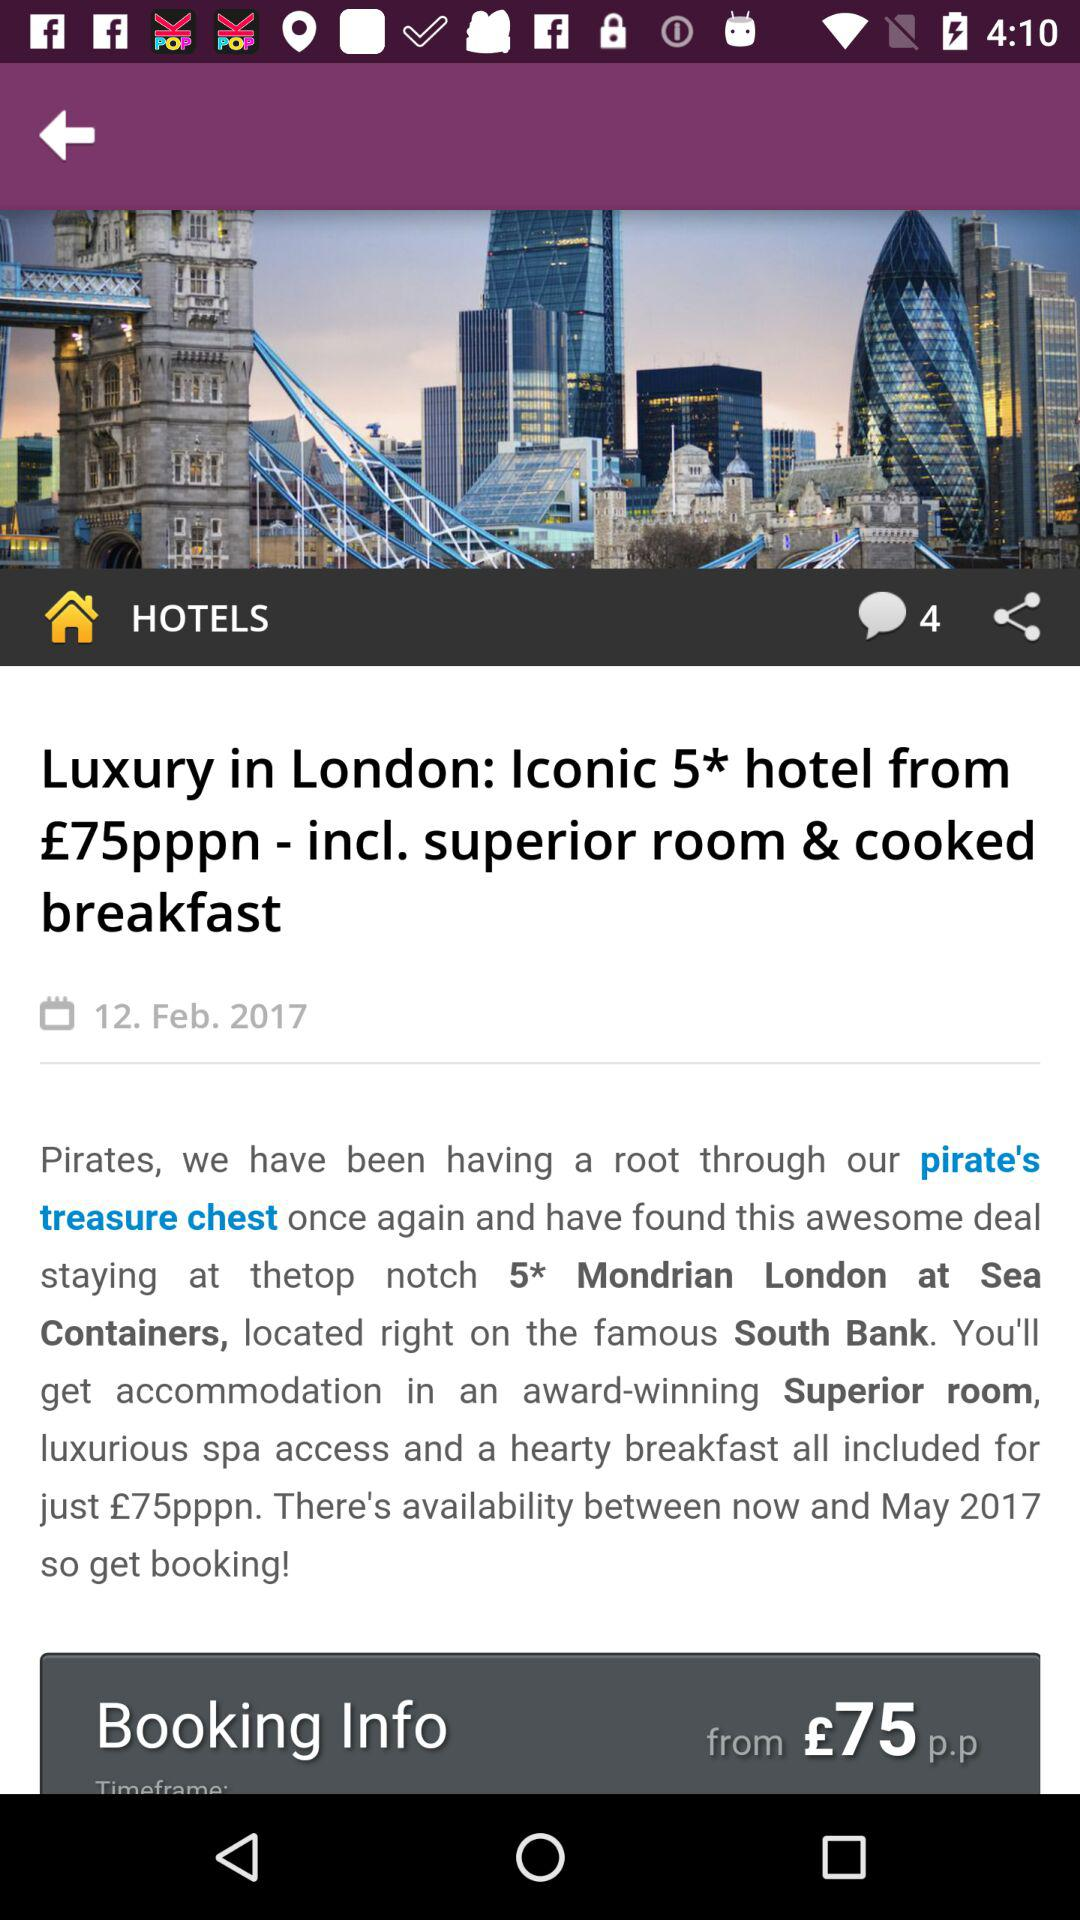What is the starting price of the reservation? The starting price of the reservation is £75 p.p. 